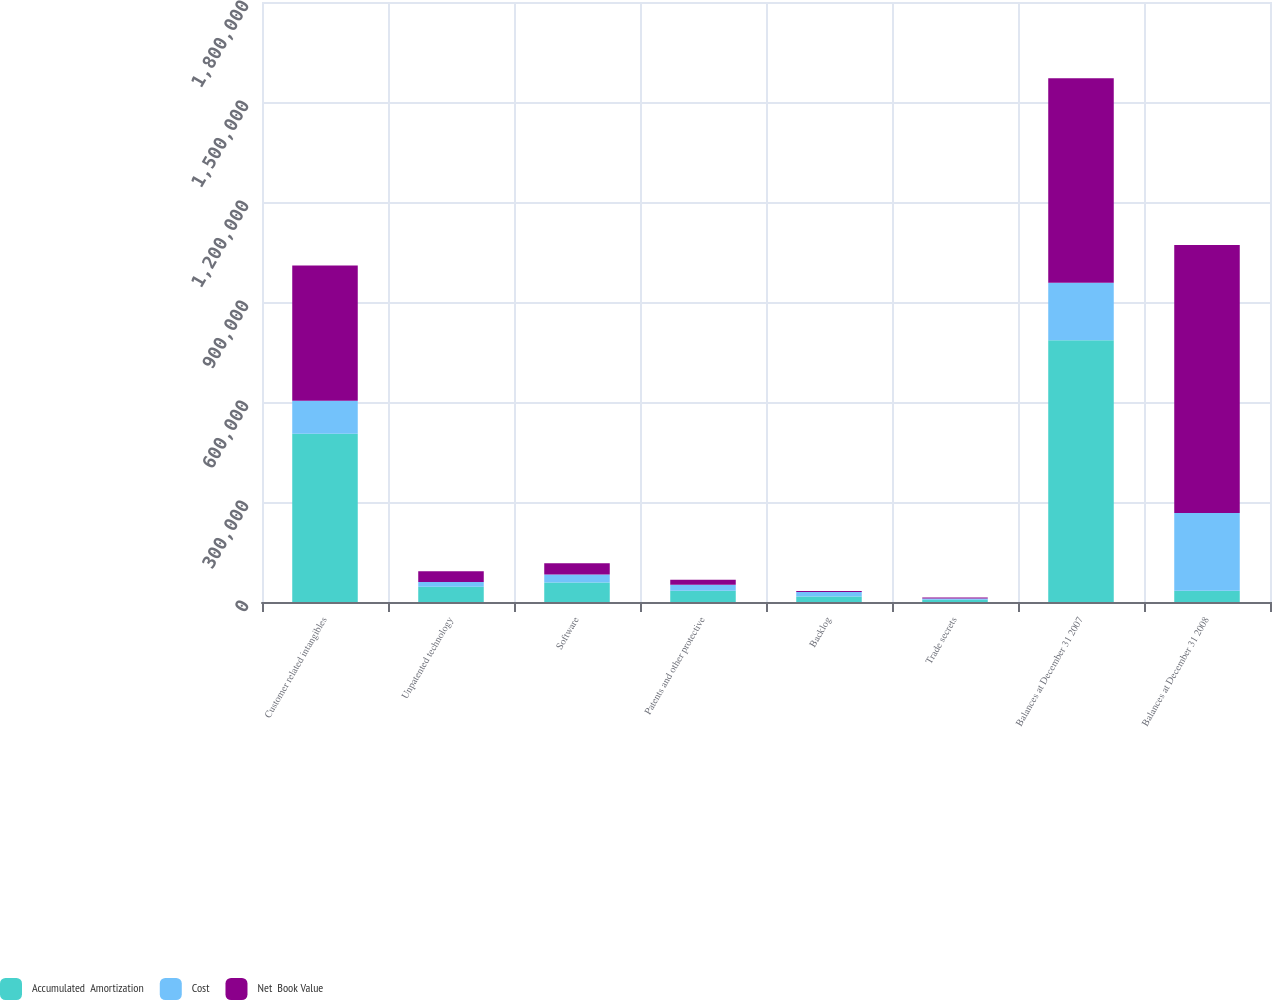Convert chart to OTSL. <chart><loc_0><loc_0><loc_500><loc_500><stacked_bar_chart><ecel><fcel>Customer related intangibles<fcel>Unpatented technology<fcel>Software<fcel>Patents and other protective<fcel>Backlog<fcel>Trade secrets<fcel>Balances at December 31 2007<fcel>Balances at December 31 2008<nl><fcel>Accumulated  Amortization<fcel>504850<fcel>46116<fcel>58152<fcel>33480<fcel>16560<fcel>6930<fcel>785461<fcel>33480<nl><fcel>Cost<fcel>99079<fcel>13714<fcel>24278<fcel>18246<fcel>13196<fcel>3443<fcel>171956<fcel>233153<nl><fcel>Net  Book Value<fcel>405771<fcel>32402<fcel>33874<fcel>15234<fcel>3364<fcel>3487<fcel>613505<fcel>804020<nl></chart> 